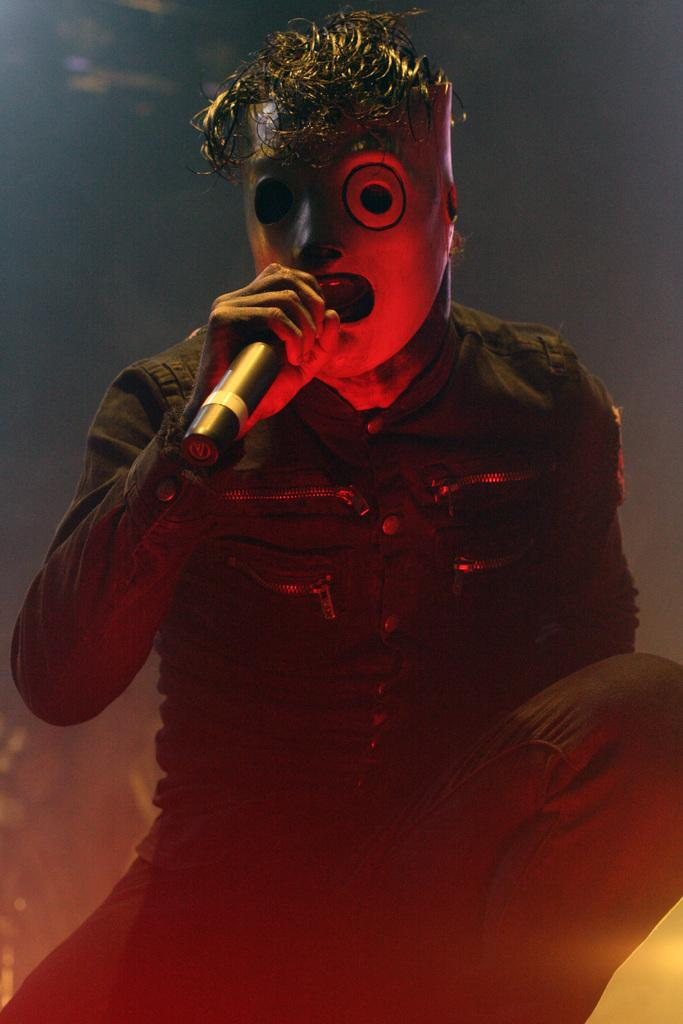What is the person in the image doing? The person is singing a song. What object is the person holding while singing? The person is holding a microphone. Can you describe the person's appearance in the image? The person is wearing a mask. What is the color of the background in the image? The background of the image is dark. What type of toy can be seen on top of the person's head in the image? There is no toy visible on top of the person's head in the image. What is the person's emotional state after experiencing a loss in the image? There is no indication of any loss or emotional state in the image; the person is simply singing with a microphone. 